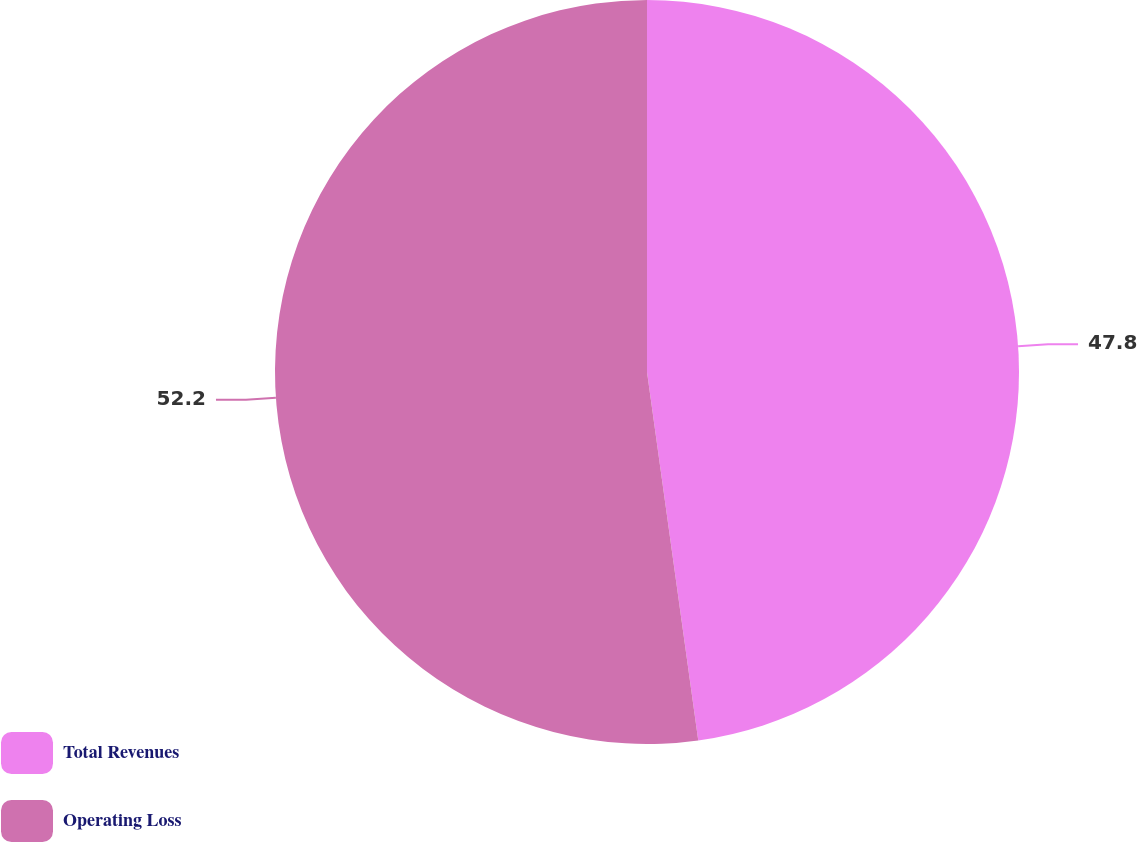Convert chart. <chart><loc_0><loc_0><loc_500><loc_500><pie_chart><fcel>Total Revenues<fcel>Operating Loss<nl><fcel>47.8%<fcel>52.2%<nl></chart> 